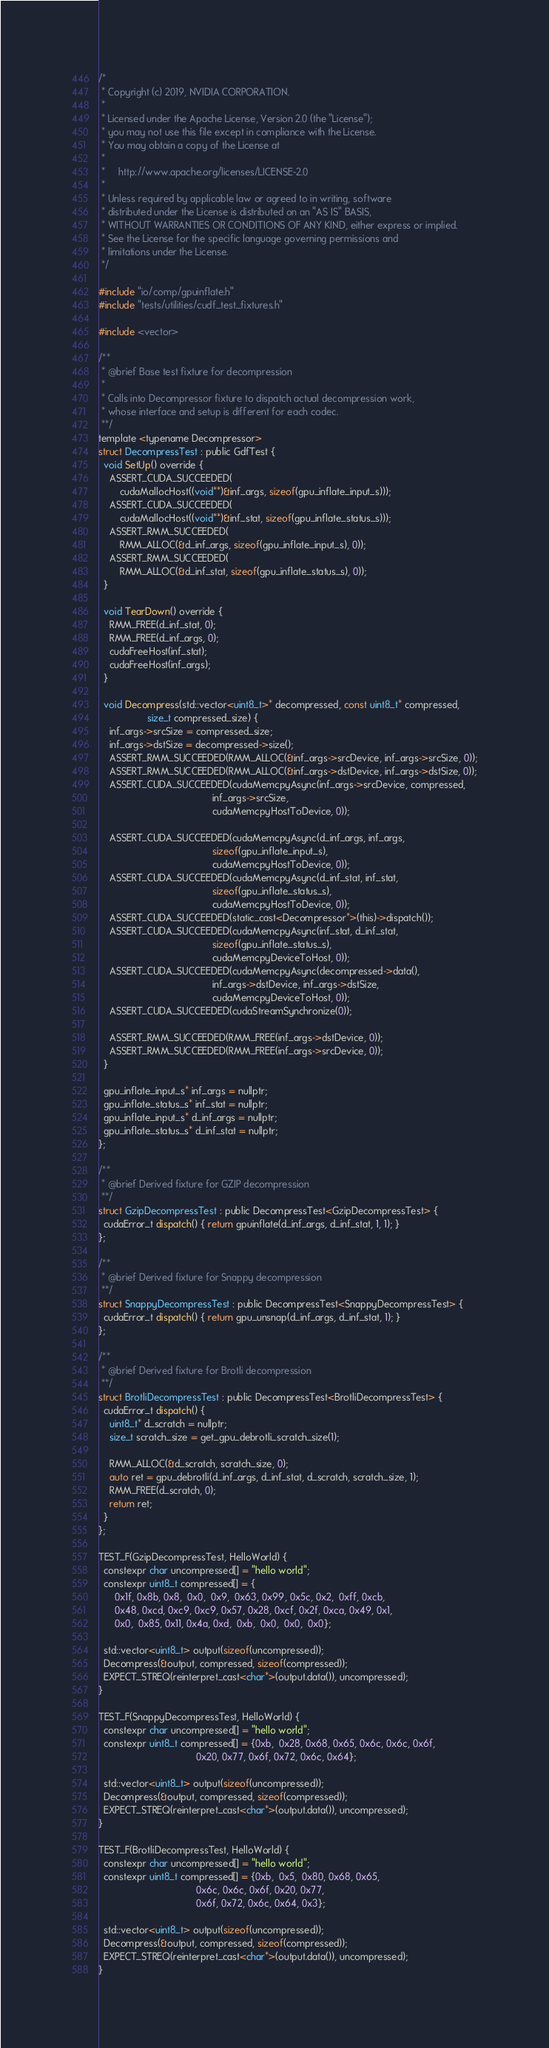Convert code to text. <code><loc_0><loc_0><loc_500><loc_500><_Cuda_>/*
 * Copyright (c) 2019, NVIDIA CORPORATION.
 *
 * Licensed under the Apache License, Version 2.0 (the "License");
 * you may not use this file except in compliance with the License.
 * You may obtain a copy of the License at
 *
 *     http://www.apache.org/licenses/LICENSE-2.0
 *
 * Unless required by applicable law or agreed to in writing, software
 * distributed under the License is distributed on an "AS IS" BASIS,
 * WITHOUT WARRANTIES OR CONDITIONS OF ANY KIND, either express or implied.
 * See the License for the specific language governing permissions and
 * limitations under the License.
 */

#include "io/comp/gpuinflate.h"
#include "tests/utilities/cudf_test_fixtures.h"

#include <vector>

/**
 * @brief Base test fixture for decompression
 *
 * Calls into Decompressor fixture to dispatch actual decompression work,
 * whose interface and setup is different for each codec.
 **/
template <typename Decompressor>
struct DecompressTest : public GdfTest {
  void SetUp() override {
    ASSERT_CUDA_SUCCEEDED(
        cudaMallocHost((void**)&inf_args, sizeof(gpu_inflate_input_s)));
    ASSERT_CUDA_SUCCEEDED(
        cudaMallocHost((void**)&inf_stat, sizeof(gpu_inflate_status_s)));
    ASSERT_RMM_SUCCEEDED(
        RMM_ALLOC(&d_inf_args, sizeof(gpu_inflate_input_s), 0));
    ASSERT_RMM_SUCCEEDED(
        RMM_ALLOC(&d_inf_stat, sizeof(gpu_inflate_status_s), 0));
  }

  void TearDown() override {
    RMM_FREE(d_inf_stat, 0);
    RMM_FREE(d_inf_args, 0);
    cudaFreeHost(inf_stat);
    cudaFreeHost(inf_args);
  }

  void Decompress(std::vector<uint8_t>* decompressed, const uint8_t* compressed,
                  size_t compressed_size) {
    inf_args->srcSize = compressed_size;
    inf_args->dstSize = decompressed->size();
    ASSERT_RMM_SUCCEEDED(RMM_ALLOC(&inf_args->srcDevice, inf_args->srcSize, 0));
    ASSERT_RMM_SUCCEEDED(RMM_ALLOC(&inf_args->dstDevice, inf_args->dstSize, 0));
    ASSERT_CUDA_SUCCEEDED(cudaMemcpyAsync(inf_args->srcDevice, compressed,
                                          inf_args->srcSize,
                                          cudaMemcpyHostToDevice, 0));

    ASSERT_CUDA_SUCCEEDED(cudaMemcpyAsync(d_inf_args, inf_args,
                                          sizeof(gpu_inflate_input_s),
                                          cudaMemcpyHostToDevice, 0));
    ASSERT_CUDA_SUCCEEDED(cudaMemcpyAsync(d_inf_stat, inf_stat,
                                          sizeof(gpu_inflate_status_s),
                                          cudaMemcpyHostToDevice, 0));
    ASSERT_CUDA_SUCCEEDED(static_cast<Decompressor*>(this)->dispatch());
    ASSERT_CUDA_SUCCEEDED(cudaMemcpyAsync(inf_stat, d_inf_stat,
                                          sizeof(gpu_inflate_status_s),
                                          cudaMemcpyDeviceToHost, 0));
    ASSERT_CUDA_SUCCEEDED(cudaMemcpyAsync(decompressed->data(),
                                          inf_args->dstDevice, inf_args->dstSize,
                                          cudaMemcpyDeviceToHost, 0));
    ASSERT_CUDA_SUCCEEDED(cudaStreamSynchronize(0));

    ASSERT_RMM_SUCCEEDED(RMM_FREE(inf_args->dstDevice, 0));
    ASSERT_RMM_SUCCEEDED(RMM_FREE(inf_args->srcDevice, 0));
  }

  gpu_inflate_input_s* inf_args = nullptr;
  gpu_inflate_status_s* inf_stat = nullptr;
  gpu_inflate_input_s* d_inf_args = nullptr;
  gpu_inflate_status_s* d_inf_stat = nullptr;
};

/**
 * @brief Derived fixture for GZIP decompression
 **/
struct GzipDecompressTest : public DecompressTest<GzipDecompressTest> {
  cudaError_t dispatch() { return gpuinflate(d_inf_args, d_inf_stat, 1, 1); }
};

/**
 * @brief Derived fixture for Snappy decompression
 **/
struct SnappyDecompressTest : public DecompressTest<SnappyDecompressTest> {
  cudaError_t dispatch() { return gpu_unsnap(d_inf_args, d_inf_stat, 1); }
};

/**
 * @brief Derived fixture for Brotli decompression
 **/
struct BrotliDecompressTest : public DecompressTest<BrotliDecompressTest> {
  cudaError_t dispatch() {
    uint8_t* d_scratch = nullptr;
    size_t scratch_size = get_gpu_debrotli_scratch_size(1);

    RMM_ALLOC(&d_scratch, scratch_size, 0);
    auto ret = gpu_debrotli(d_inf_args, d_inf_stat, d_scratch, scratch_size, 1);
    RMM_FREE(d_scratch, 0);
    return ret;
  }
};

TEST_F(GzipDecompressTest, HelloWorld) {
  constexpr char uncompressed[] = "hello world";
  constexpr uint8_t compressed[] = {
      0x1f, 0x8b, 0x8,  0x0,  0x9,  0x63, 0x99, 0x5c, 0x2,  0xff, 0xcb,
      0x48, 0xcd, 0xc9, 0xc9, 0x57, 0x28, 0xcf, 0x2f, 0xca, 0x49, 0x1,
      0x0,  0x85, 0x11, 0x4a, 0xd,  0xb,  0x0,  0x0,  0x0};

  std::vector<uint8_t> output(sizeof(uncompressed));
  Decompress(&output, compressed, sizeof(compressed));
  EXPECT_STREQ(reinterpret_cast<char*>(output.data()), uncompressed);
}

TEST_F(SnappyDecompressTest, HelloWorld) {
  constexpr char uncompressed[] = "hello world";
  constexpr uint8_t compressed[] = {0xb,  0x28, 0x68, 0x65, 0x6c, 0x6c, 0x6f,
                                    0x20, 0x77, 0x6f, 0x72, 0x6c, 0x64};

  std::vector<uint8_t> output(sizeof(uncompressed));
  Decompress(&output, compressed, sizeof(compressed));
  EXPECT_STREQ(reinterpret_cast<char*>(output.data()), uncompressed);
}

TEST_F(BrotliDecompressTest, HelloWorld) {
  constexpr char uncompressed[] = "hello world";
  constexpr uint8_t compressed[] = {0xb,  0x5,  0x80, 0x68, 0x65,
                                    0x6c, 0x6c, 0x6f, 0x20, 0x77,
                                    0x6f, 0x72, 0x6c, 0x64, 0x3};

  std::vector<uint8_t> output(sizeof(uncompressed));
  Decompress(&output, compressed, sizeof(compressed));
  EXPECT_STREQ(reinterpret_cast<char*>(output.data()), uncompressed);
}
</code> 